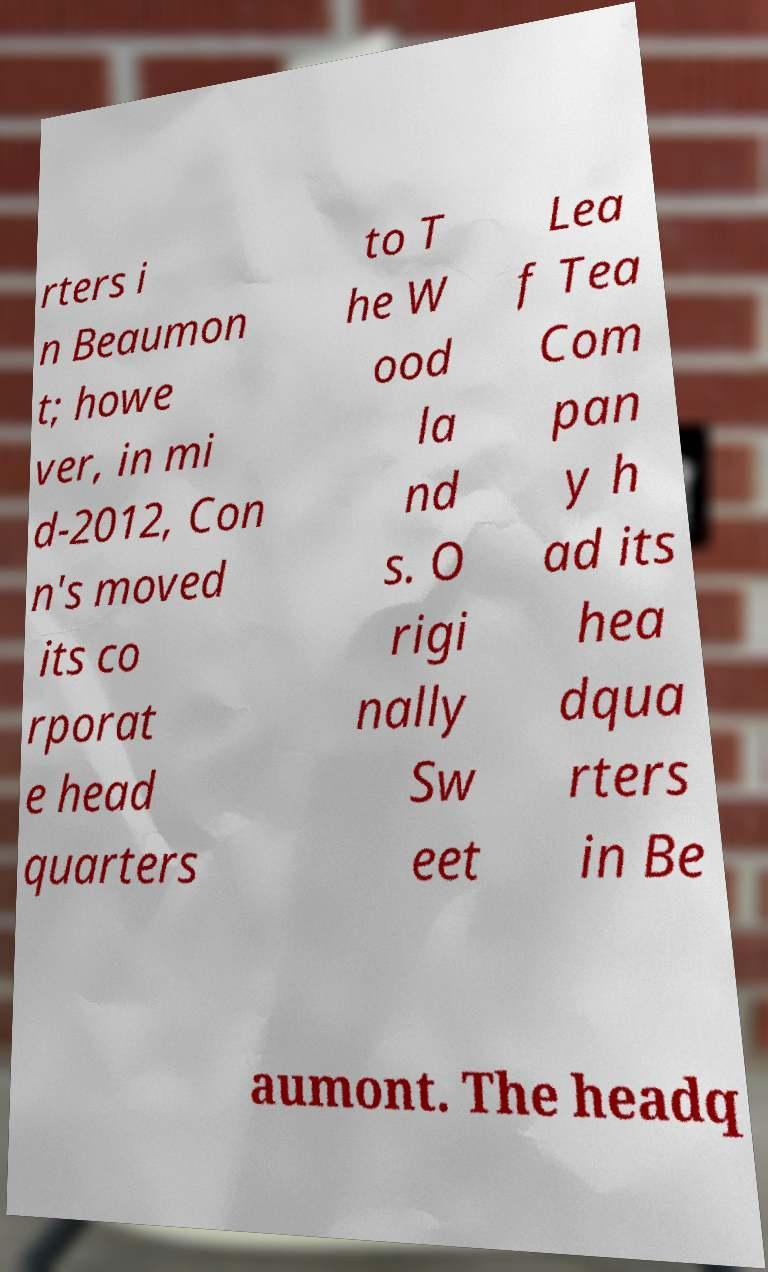Could you extract and type out the text from this image? rters i n Beaumon t; howe ver, in mi d-2012, Con n's moved its co rporat e head quarters to T he W ood la nd s. O rigi nally Sw eet Lea f Tea Com pan y h ad its hea dqua rters in Be aumont. The headq 